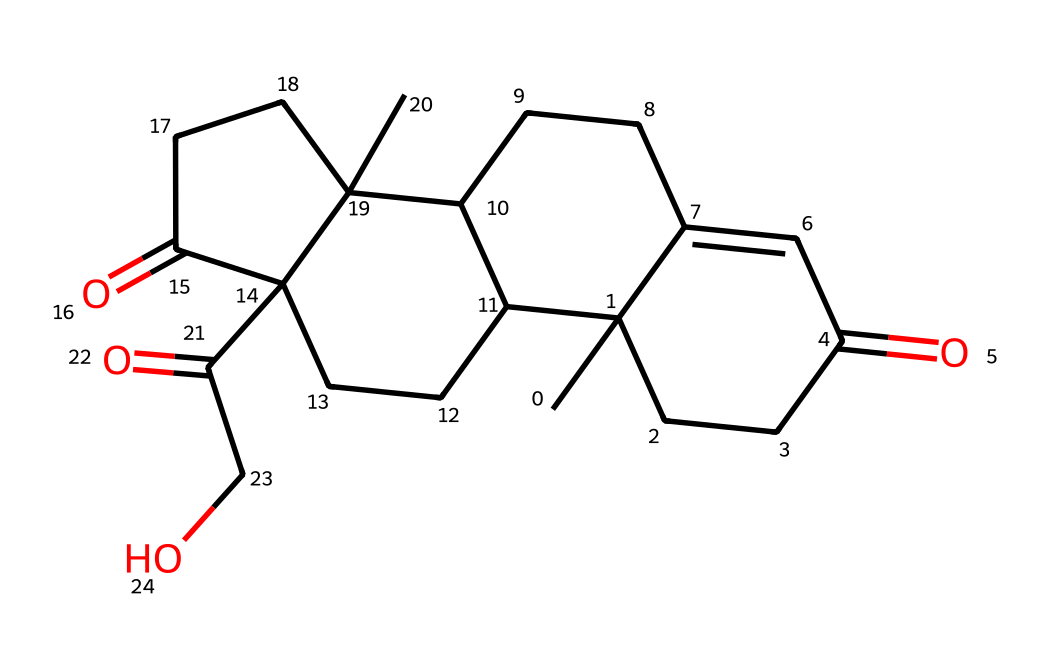What is the molecular weight of cortisol? The molecular weight can be calculated from the number of each type of atom in the SMILES representation. By identifying the atoms (C, H, O) and their respective counts, we can compute it as follows: 21 carbon (C) atoms each weighing approximately 12.01 g/mol, 30 hydrogen (H) atoms each weighing about 1.008 g/mol, and 5 oxygen (O) atoms each weighing roughly 16.00 g/mol. Summing these gives a total molecular weight of approximately 362.46 g/mol.
Answer: 362.46 g/mol How many carbon atoms are in cortisol? By analyzing the SMILES representation, we can count the number of 'C' characters. After reviewing, it shows there are 21 'C' atoms present in the structure.
Answer: 21 What type of functional groups are present in cortisol? The presence of 'C(=O)' in the chemical structure indicates that cortisol contains ketone (C=O) and hydroxyl (-OH) functional groups. These groups are critical for its biochemical activity.
Answer: ketone and hydroxyl Are there any double bonds in the structure of cortisol? The presence of '=' in the SMILES string indicates double bonds between some carbon atoms. Scanning through the structure reveals several double bonds, confirming their existence.
Answer: yes What are the implications of cortisol's structure on its biological function? Cortisol's structure, particularly the presence of the ketone and hydroxyl groups, allows it to bind to the glucocorticoid receptor, influencing various biological pathways related to stress response, metabolism, and inflammation.
Answer: energy regulation How does cortisol relate to the concept of stress hormone in political engagement? Cortisol is often referred to as the stress hormone due to its release in response to stress. Engaged individuals may have elevated cortisol levels, which reflects both their psychological and physiological responses to the stressors associated with political activity.
Answer: elevated in engaged individuals What is the significance of the cyclic structure in cortisol? The cyclic structure contributes to the stability and specificity of cortisol's interactions with biological receptors. The rings allow for a three-dimensional shape that is critical for its effectiveness as a hormone.
Answer: stability and specificity 